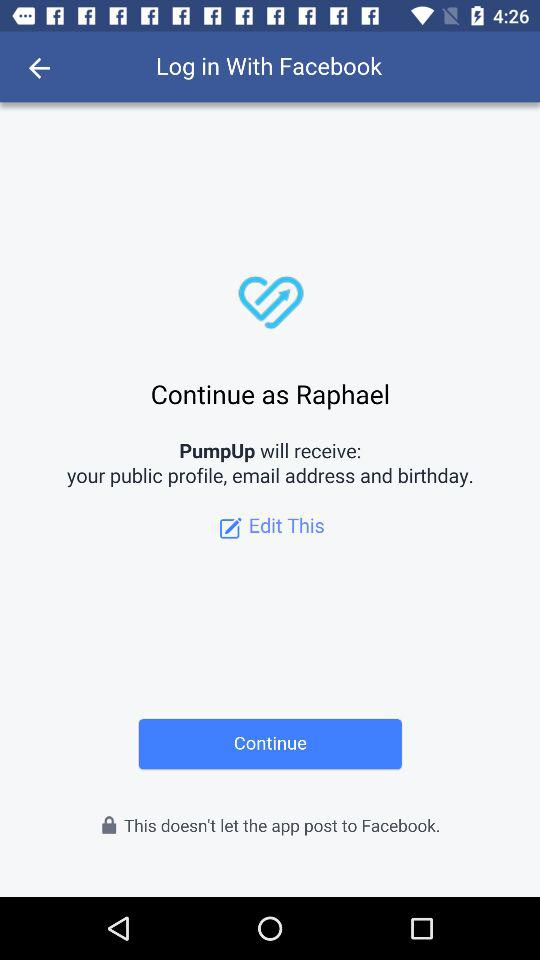What application is asking for permission? The application asking for permission is "PumpUp". 